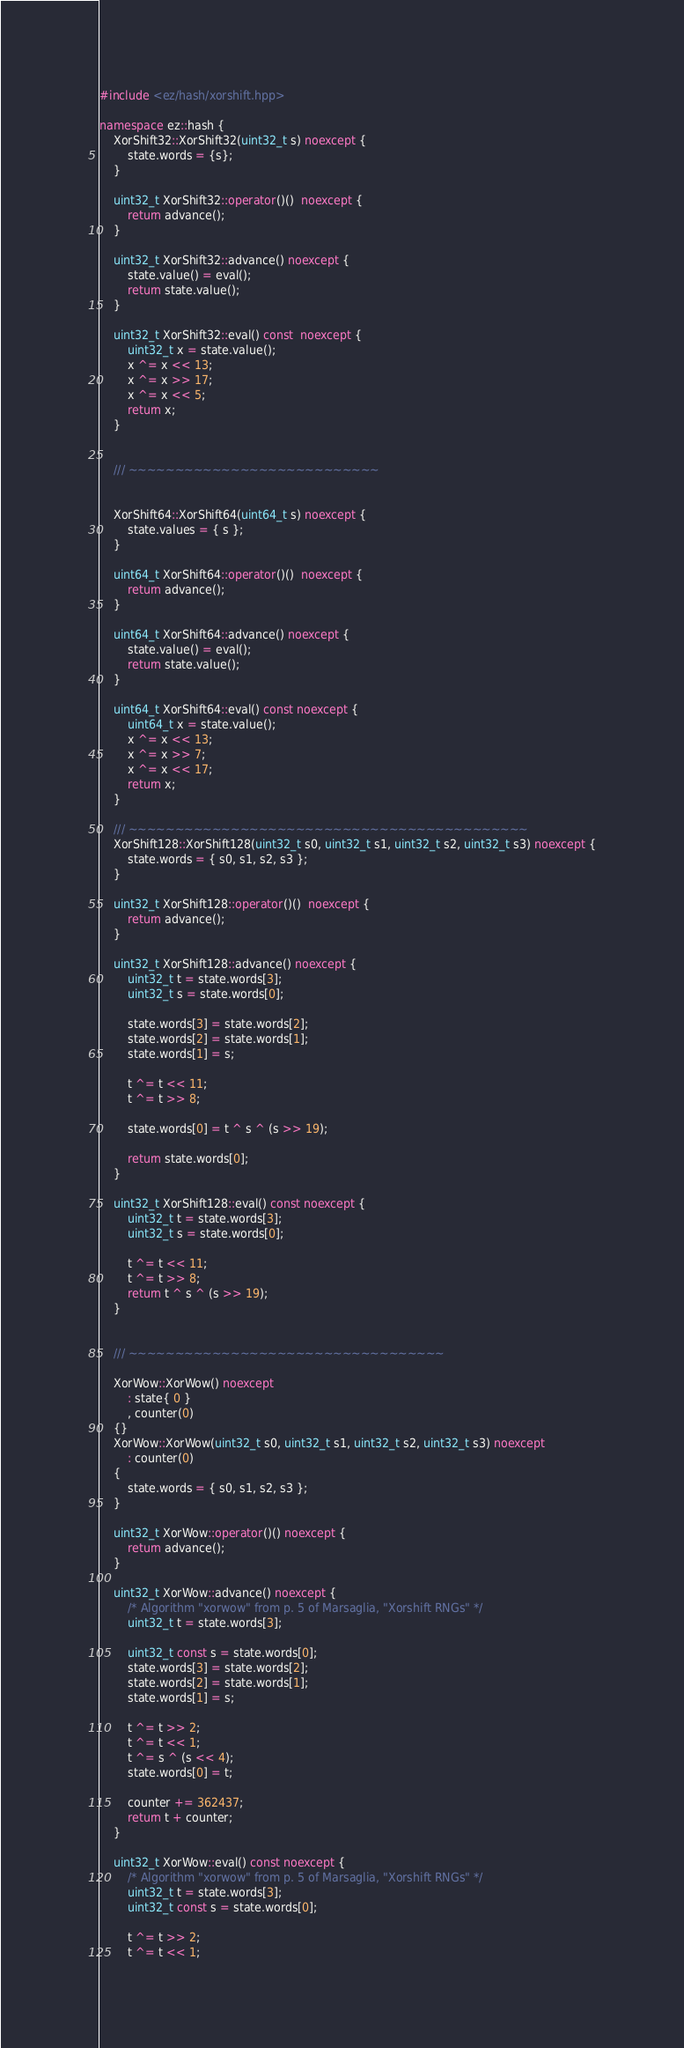Convert code to text. <code><loc_0><loc_0><loc_500><loc_500><_C++_>#include <ez/hash/xorshift.hpp>

namespace ez::hash {
	XorShift32::XorShift32(uint32_t s) noexcept {
		state.words = {s};
	}

	uint32_t XorShift32::operator()()  noexcept {
		return advance();
	}

	uint32_t XorShift32::advance() noexcept {
		state.value() = eval();
		return state.value();
	}

	uint32_t XorShift32::eval() const  noexcept {
		uint32_t x = state.value();
		x ^= x << 13;
		x ^= x >> 17;
		x ^= x << 5;
		return x;
	}


	/// ~~~~~~~~~~~~~~~~~~~~~~~~~~~


	XorShift64::XorShift64(uint64_t s) noexcept {
		state.values = { s };
	}

	uint64_t XorShift64::operator()()  noexcept {
		return advance();
	}

	uint64_t XorShift64::advance() noexcept {
		state.value() = eval();
		return state.value();
	}

	uint64_t XorShift64::eval() const noexcept {
		uint64_t x = state.value();
		x ^= x << 13;
		x ^= x >> 7;
		x ^= x << 17;
		return x;
	}

	/// ~~~~~~~~~~~~~~~~~~~~~~~~~~~~~~~~~~~~~~~~~~~
	XorShift128::XorShift128(uint32_t s0, uint32_t s1, uint32_t s2, uint32_t s3) noexcept {
		state.words = { s0, s1, s2, s3 };
	}

	uint32_t XorShift128::operator()()  noexcept {
		return advance();
	}

	uint32_t XorShift128::advance() noexcept {
		uint32_t t = state.words[3];
		uint32_t s = state.words[0];

		state.words[3] = state.words[2];
		state.words[2] = state.words[1];
		state.words[1] = s;

		t ^= t << 11;
		t ^= t >> 8;

		state.words[0] = t ^ s ^ (s >> 19);

		return state.words[0];
	}

	uint32_t XorShift128::eval() const noexcept {
		uint32_t t = state.words[3];
		uint32_t s = state.words[0];

		t ^= t << 11;
		t ^= t >> 8;
		return t ^ s ^ (s >> 19);
	}


	/// ~~~~~~~~~~~~~~~~~~~~~~~~~~~~~~~~~~

	XorWow::XorWow() noexcept
		: state{ 0 }
		, counter(0)
	{}
	XorWow::XorWow(uint32_t s0, uint32_t s1, uint32_t s2, uint32_t s3) noexcept
		: counter(0)
	{
		state.words = { s0, s1, s2, s3 };
	}

	uint32_t XorWow::operator()() noexcept {
		return advance();
	}

	uint32_t XorWow::advance() noexcept {
		/* Algorithm "xorwow" from p. 5 of Marsaglia, "Xorshift RNGs" */
		uint32_t t = state.words[3];

		uint32_t const s = state.words[0];
		state.words[3] = state.words[2];
		state.words[2] = state.words[1];
		state.words[1] = s;

		t ^= t >> 2;
		t ^= t << 1;
		t ^= s ^ (s << 4);
		state.words[0] = t;

		counter += 362437;
		return t + counter;
	}

	uint32_t XorWow::eval() const noexcept {
		/* Algorithm "xorwow" from p. 5 of Marsaglia, "Xorshift RNGs" */
		uint32_t t = state.words[3];
		uint32_t const s = state.words[0];

		t ^= t >> 2;
		t ^= t << 1;</code> 